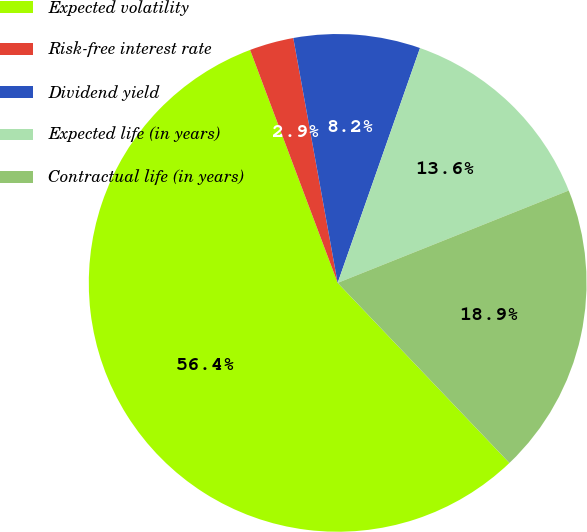Convert chart to OTSL. <chart><loc_0><loc_0><loc_500><loc_500><pie_chart><fcel>Expected volatility<fcel>Risk-free interest rate<fcel>Dividend yield<fcel>Expected life (in years)<fcel>Contractual life (in years)<nl><fcel>56.4%<fcel>2.87%<fcel>8.22%<fcel>13.58%<fcel>18.93%<nl></chart> 